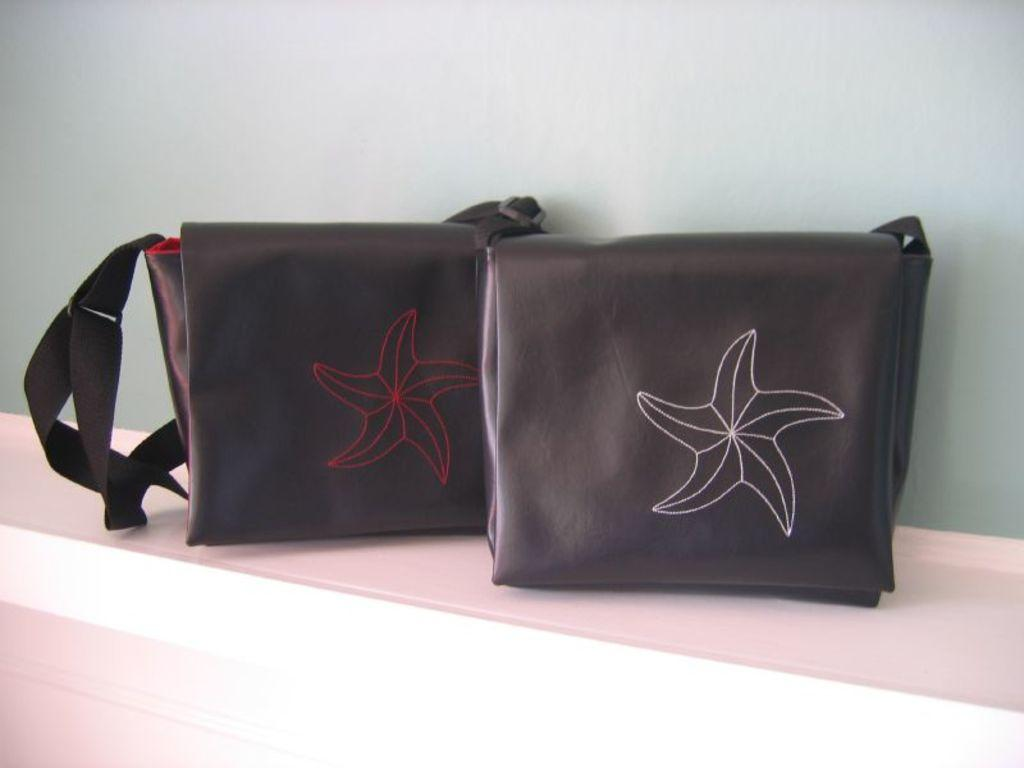How many handbags are visible in the image? There are two handbags in the image. Where are the handbags located? The handbags are on a shelf. What design element is present on the handbags? The handbags have a flower symbol on them. How does the lace on the handbags contribute to the overall design? There is no lace present on the handbags in the image. 